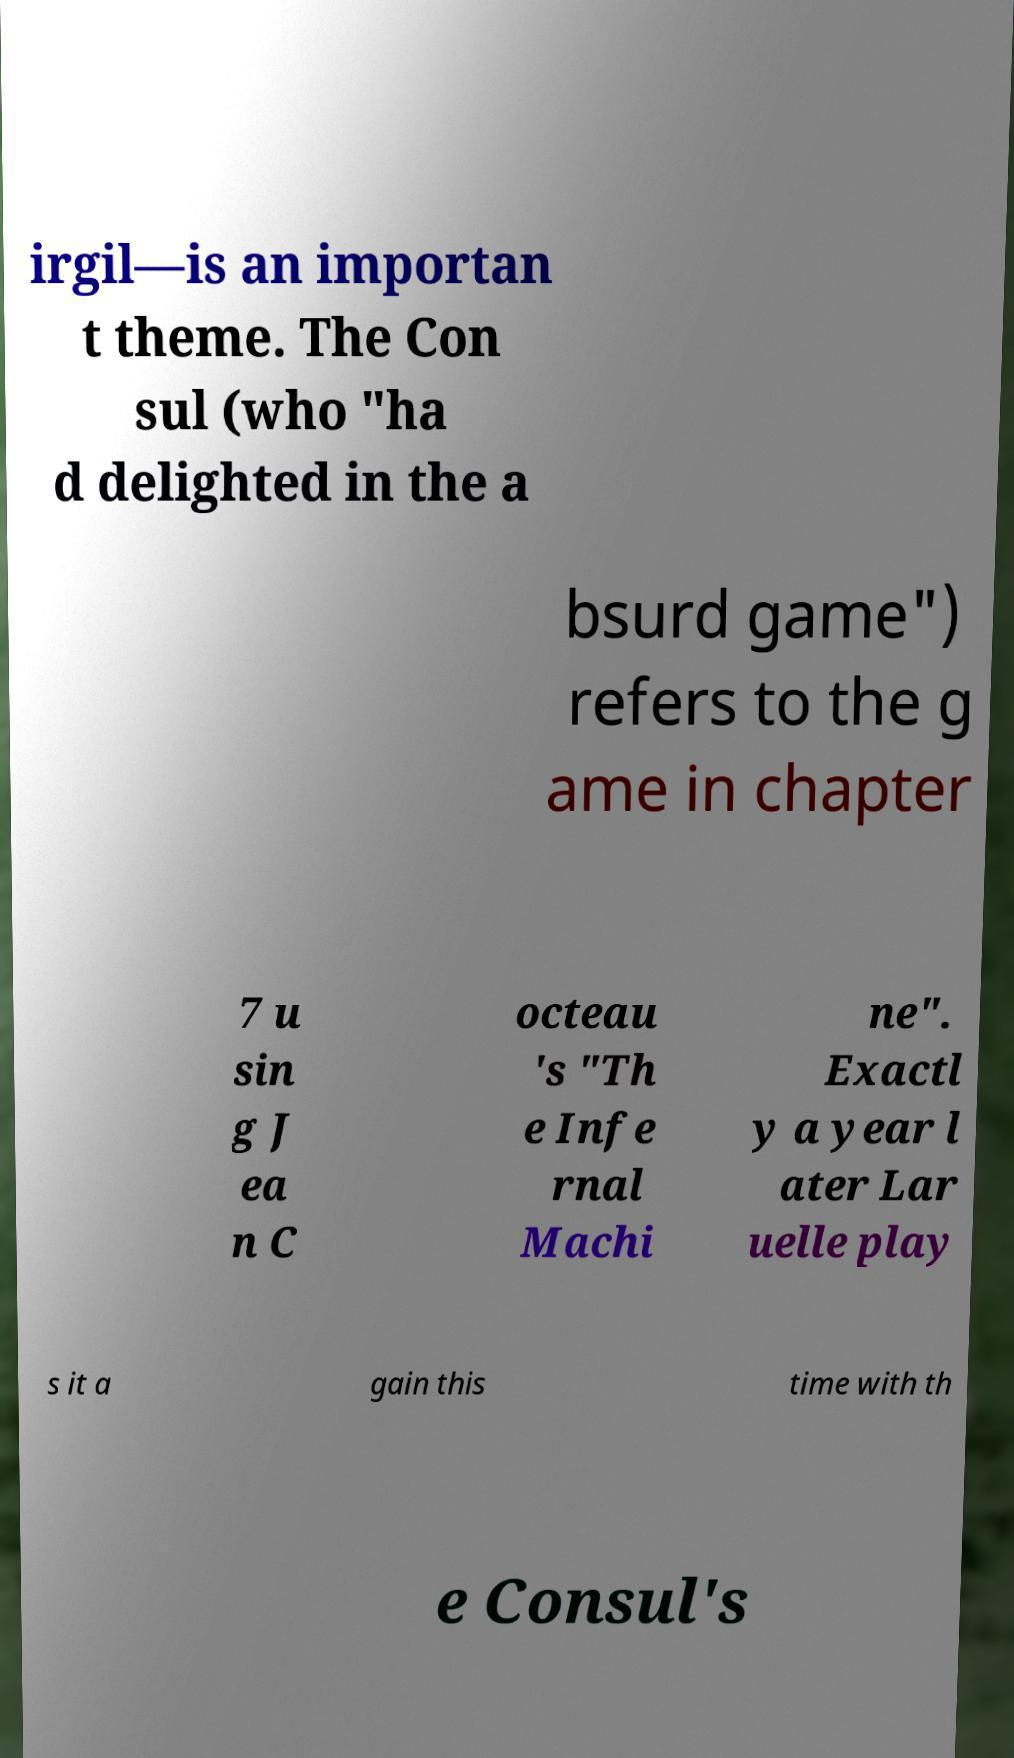Can you read and provide the text displayed in the image?This photo seems to have some interesting text. Can you extract and type it out for me? irgil—is an importan t theme. The Con sul (who "ha d delighted in the a bsurd game") refers to the g ame in chapter 7 u sin g J ea n C octeau 's "Th e Infe rnal Machi ne". Exactl y a year l ater Lar uelle play s it a gain this time with th e Consul's 